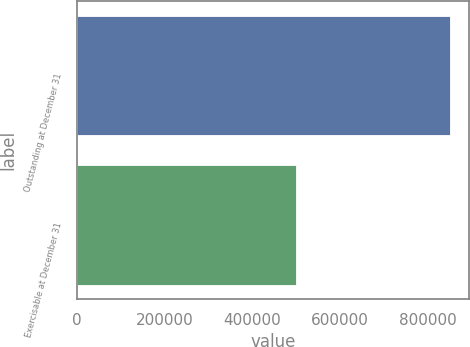Convert chart. <chart><loc_0><loc_0><loc_500><loc_500><bar_chart><fcel>Outstanding at December 31<fcel>Exercisable at December 31<nl><fcel>850628<fcel>499572<nl></chart> 